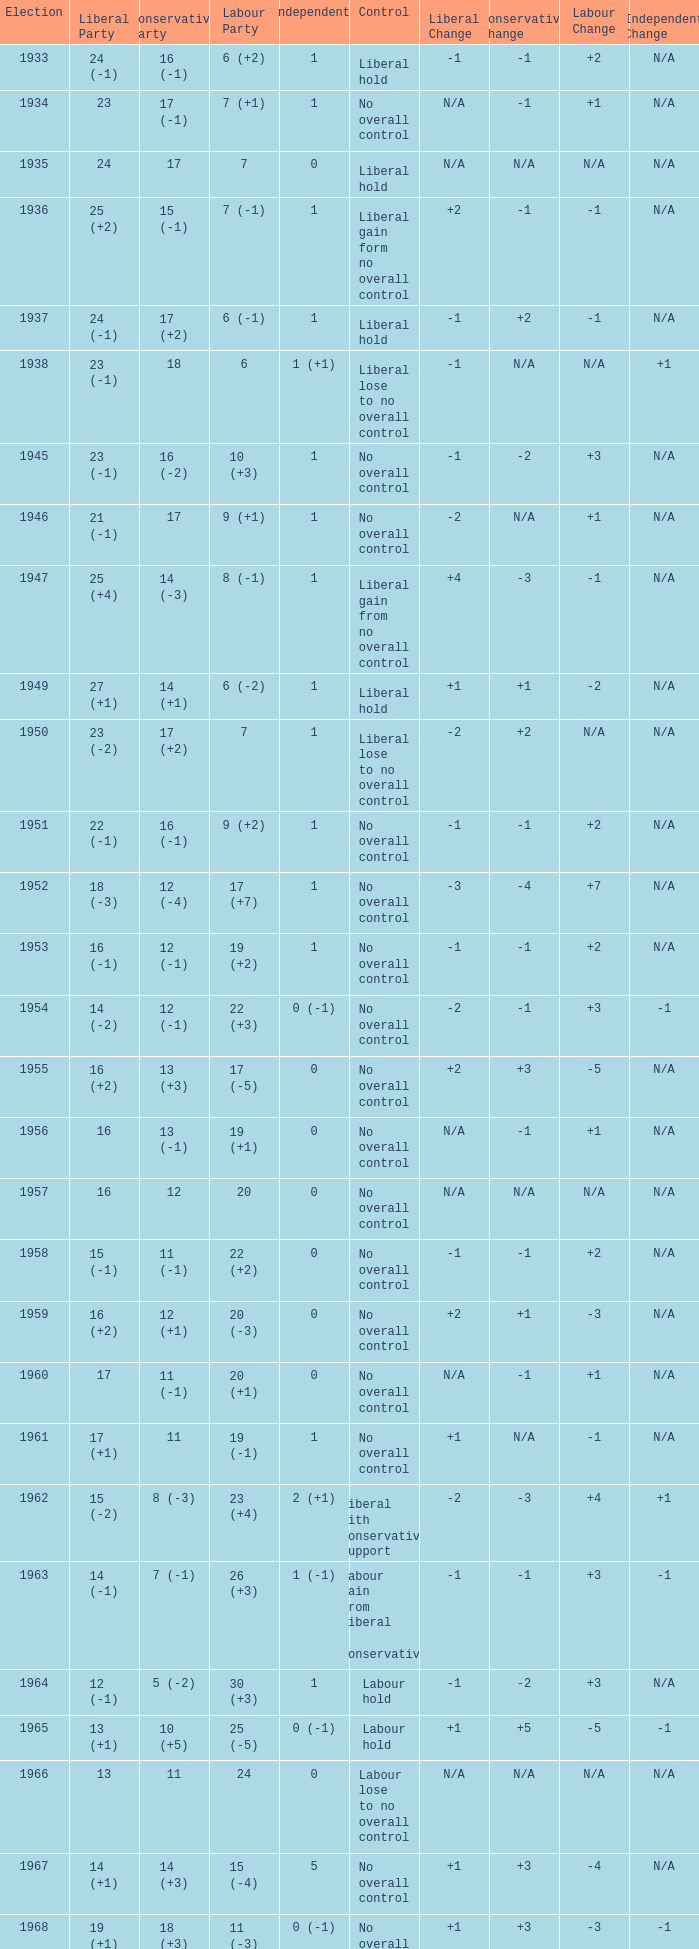Who was in control the year that Labour Party won 12 (+6) seats? No overall control (1 vacancy). Could you help me parse every detail presented in this table? {'header': ['Election', 'Liberal Party', 'Conservative Party', 'Labour Party', 'Independents', 'Control', 'Liberal Change', 'Conservative Change', 'Labour Change', 'Independent Change'], 'rows': [['1933', '24 (-1)', '16 (-1)', '6 (+2)', '1', 'Liberal hold', '-1', '-1', '+2', 'N/A'], ['1934', '23', '17 (-1)', '7 (+1)', '1', 'No overall control', 'N/A', '-1', '+1', 'N/A'], ['1935', '24', '17', '7', '0', 'Liberal hold', 'N/A', 'N/A', 'N/A', 'N/A'], ['1936', '25 (+2)', '15 (-1)', '7 (-1)', '1', 'Liberal gain form no overall control', '+2', '-1', '-1', 'N/A'], ['1937', '24 (-1)', '17 (+2)', '6 (-1)', '1', 'Liberal hold', '-1', '+2', '-1', 'N/A'], ['1938', '23 (-1)', '18', '6', '1 (+1)', 'Liberal lose to no overall control', '-1', 'N/A', 'N/A', '+1'], ['1945', '23 (-1)', '16 (-2)', '10 (+3)', '1', 'No overall control', '-1', '-2', '+3', 'N/A'], ['1946', '21 (-1)', '17', '9 (+1)', '1', 'No overall control', '-2', 'N/A', '+1', 'N/A'], ['1947', '25 (+4)', '14 (-3)', '8 (-1)', '1', 'Liberal gain from no overall control', '+4', '-3', '-1', 'N/A'], ['1949', '27 (+1)', '14 (+1)', '6 (-2)', '1', 'Liberal hold', '+1', '+1', '-2', 'N/A'], ['1950', '23 (-2)', '17 (+2)', '7', '1', 'Liberal lose to no overall control', '-2', '+2', 'N/A', 'N/A'], ['1951', '22 (-1)', '16 (-1)', '9 (+2)', '1', 'No overall control', '-1', '-1', '+2', 'N/A'], ['1952', '18 (-3)', '12 (-4)', '17 (+7)', '1', 'No overall control', '-3', '-4', '+7', 'N/A'], ['1953', '16 (-1)', '12 (-1)', '19 (+2)', '1', 'No overall control', '-1', '-1', '+2', 'N/A'], ['1954', '14 (-2)', '12 (-1)', '22 (+3)', '0 (-1)', 'No overall control', '-2', '-1', '+3', '-1'], ['1955', '16 (+2)', '13 (+3)', '17 (-5)', '0', 'No overall control', '+2', '+3', '-5', 'N/A'], ['1956', '16', '13 (-1)', '19 (+1)', '0', 'No overall control', 'N/A', '-1', '+1', 'N/A'], ['1957', '16', '12', '20', '0', 'No overall control', 'N/A', 'N/A', 'N/A', 'N/A'], ['1958', '15 (-1)', '11 (-1)', '22 (+2)', '0', 'No overall control', '-1', '-1', '+2', 'N/A'], ['1959', '16 (+2)', '12 (+1)', '20 (-3)', '0', 'No overall control', '+2', '+1', '-3', 'N/A'], ['1960', '17', '11 (-1)', '20 (+1)', '0', 'No overall control', 'N/A', '-1', '+1', 'N/A'], ['1961', '17 (+1)', '11', '19 (-1)', '1', 'No overall control', '+1', 'N/A', '-1', 'N/A'], ['1962', '15 (-2)', '8 (-3)', '23 (+4)', '2 (+1)', 'Liberal with Conservative support', '-2', '-3', '+4', '+1'], ['1963', '14 (-1)', '7 (-1)', '26 (+3)', '1 (-1)', 'Labour gain from Liberal - Conservative', '-1', '-1', '+3', '-1'], ['1964', '12 (-1)', '5 (-2)', '30 (+3)', '1', 'Labour hold', '-1', '-2', '+3', 'N/A'], ['1965', '13 (+1)', '10 (+5)', '25 (-5)', '0 (-1)', 'Labour hold', '+1', '+5', '-5', '-1'], ['1966', '13', '11', '24', '0', 'Labour lose to no overall control', 'N/A', 'N/A', 'N/A', 'N/A'], ['1967', '14 (+1)', '14 (+3)', '15 (-4)', '5', 'No overall control', '+1', '+3', '-4', 'N/A'], ['1968', '19 (+1)', '18 (+3)', '11 (-3)', '0 (-1)', 'No overall control', '+1', '+3', '-3', '-1'], ['1969', '20 (+1)', '21 (+3)', '7 (-4)', '0', 'No overall control', '+1', '+3', '-4', 'N/A'], ['1970', '15 (-2)', '19 (-4)', '12 (+6)', '1', 'No overall control (1 vacancy)', '-2', '-4', '+6', 'N/A'], ['1971', '11 (-2)', '14 (-5)', '22 (+7)', '1', 'No overall control', '-2', '-5', '+7', 'N/A'], ['1972', '9 (-4)', '11 (-1)', '28 (+6)', '0 (-1)', 'Labour gain from no overall control', '-4', '-1', '+6', '-1']]} 